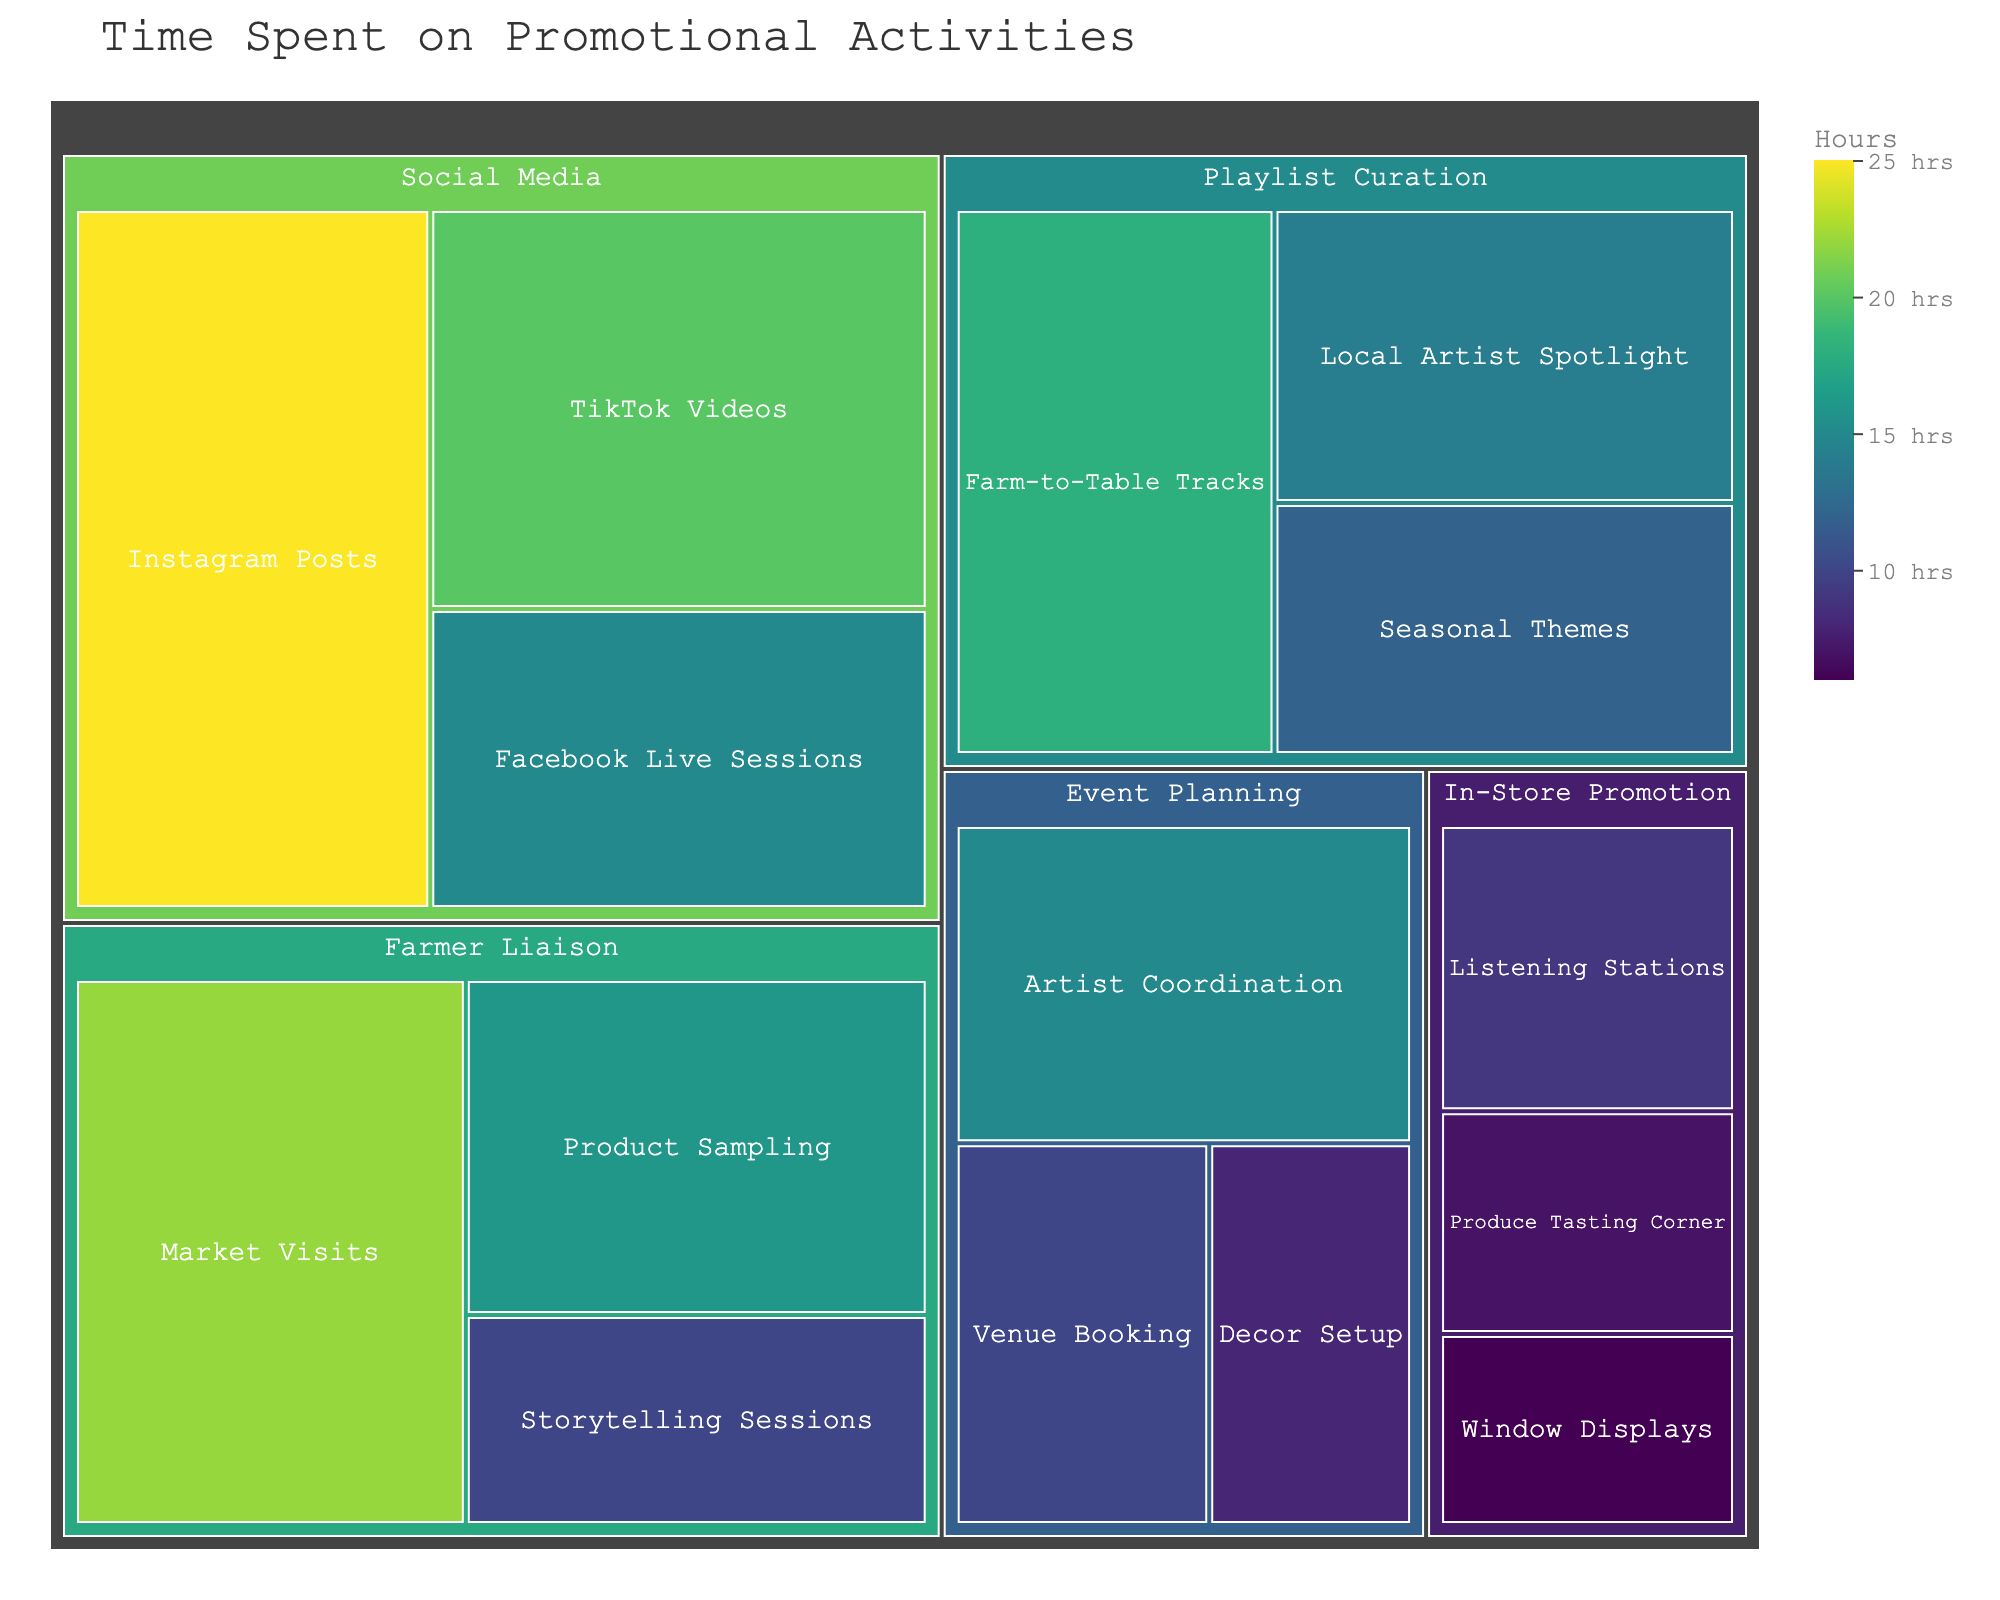What's the total number of hours spent on Social Media activities? Sum the hours spent on Instagram Posts (25), Facebook Live Sessions (15), and TikTok Videos (20). Thus, 25 + 15 + 20 = 60 hours.
Answer: 60 Which subcategory in Event Planning has the least hours spent? Compare the hours spent on Venue Booking (10), Artist Coordination (15), and Decor Setup (8). The least is Decor Setup with 8 hours.
Answer: Decor Setup How much more time is spent on TikTok Videos compared to Facebook Live Sessions? Subtract the hours spent on Facebook Live Sessions (15) from TikTok Videos (20). Thus, 20 - 15 = 5 hours.
Answer: 5 Which category has the highest total hours spent? Calculate the total hours for each category: Social Media (60), Event Planning (33), Playlist Curation (44), Farmer Liaison (48), In-Store Promotion (22). The highest is Social Media with 60 hours.
Answer: Social Media What's the combined number of hours spent on Playlist Curation and Farmer Liaison? Sum the hours of Seasonal Themes (12), Farm-to-Table Tracks (18), Local Artist Spotlight (14), Market Visits (22), Product Sampling (16), Storytelling Sessions (10). Thus, 12 + 18 + 14 + 22 + 16 + 10 = 92 hours.
Answer: 92 Which subcategory within Farmer Liaison has the most hours? Compare the hours spent on Market Visits (22), Product Sampling (16), and Storytelling Sessions (10). The most is Market Visits with 22 hours.
Answer: Market Visits How many hours are spent on Window Displays and Listening Stations combined? Sum the hours spent on Window Displays (6) and Listening Stations (9). Thus, 6 + 9 = 15 hours.
Answer: 15 What's the difference in hours between the highest and lowest subcategory in Playlist Curation? Identify the highest (Farm-to-Table Tracks with 18 hours) and lowest (Seasonal Themes with 12 hours). Subtract 12 from 18. Thus, 18 - 12 = 6 hours.
Answer: 6 What is the average number of hours spent on In-Store Promotion activities? Find the total hours spent on Window Displays (6), Listening Stations (9), Produce Tasting Corner (7). Sum them up (6 + 9 + 7 = 22) and divide by the number of subcategories (3). Thus, 22 / 3 ≈ 7.33.
Answer: 7.33 